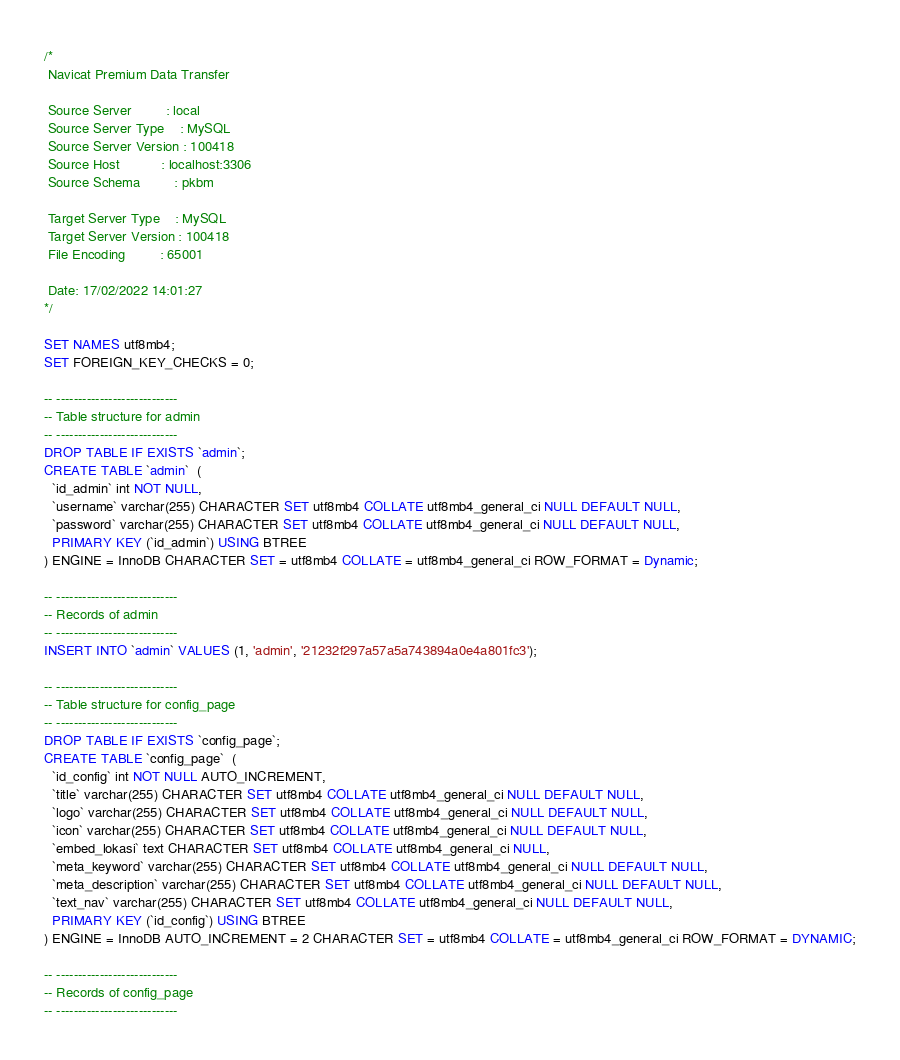Convert code to text. <code><loc_0><loc_0><loc_500><loc_500><_SQL_>/*
 Navicat Premium Data Transfer

 Source Server         : local
 Source Server Type    : MySQL
 Source Server Version : 100418
 Source Host           : localhost:3306
 Source Schema         : pkbm

 Target Server Type    : MySQL
 Target Server Version : 100418
 File Encoding         : 65001

 Date: 17/02/2022 14:01:27
*/

SET NAMES utf8mb4;
SET FOREIGN_KEY_CHECKS = 0;

-- ----------------------------
-- Table structure for admin
-- ----------------------------
DROP TABLE IF EXISTS `admin`;
CREATE TABLE `admin`  (
  `id_admin` int NOT NULL,
  `username` varchar(255) CHARACTER SET utf8mb4 COLLATE utf8mb4_general_ci NULL DEFAULT NULL,
  `password` varchar(255) CHARACTER SET utf8mb4 COLLATE utf8mb4_general_ci NULL DEFAULT NULL,
  PRIMARY KEY (`id_admin`) USING BTREE
) ENGINE = InnoDB CHARACTER SET = utf8mb4 COLLATE = utf8mb4_general_ci ROW_FORMAT = Dynamic;

-- ----------------------------
-- Records of admin
-- ----------------------------
INSERT INTO `admin` VALUES (1, 'admin', '21232f297a57a5a743894a0e4a801fc3');

-- ----------------------------
-- Table structure for config_page
-- ----------------------------
DROP TABLE IF EXISTS `config_page`;
CREATE TABLE `config_page`  (
  `id_config` int NOT NULL AUTO_INCREMENT,
  `title` varchar(255) CHARACTER SET utf8mb4 COLLATE utf8mb4_general_ci NULL DEFAULT NULL,
  `logo` varchar(255) CHARACTER SET utf8mb4 COLLATE utf8mb4_general_ci NULL DEFAULT NULL,
  `icon` varchar(255) CHARACTER SET utf8mb4 COLLATE utf8mb4_general_ci NULL DEFAULT NULL,
  `embed_lokasi` text CHARACTER SET utf8mb4 COLLATE utf8mb4_general_ci NULL,
  `meta_keyword` varchar(255) CHARACTER SET utf8mb4 COLLATE utf8mb4_general_ci NULL DEFAULT NULL,
  `meta_description` varchar(255) CHARACTER SET utf8mb4 COLLATE utf8mb4_general_ci NULL DEFAULT NULL,
  `text_nav` varchar(255) CHARACTER SET utf8mb4 COLLATE utf8mb4_general_ci NULL DEFAULT NULL,
  PRIMARY KEY (`id_config`) USING BTREE
) ENGINE = InnoDB AUTO_INCREMENT = 2 CHARACTER SET = utf8mb4 COLLATE = utf8mb4_general_ci ROW_FORMAT = DYNAMIC;

-- ----------------------------
-- Records of config_page
-- ----------------------------</code> 